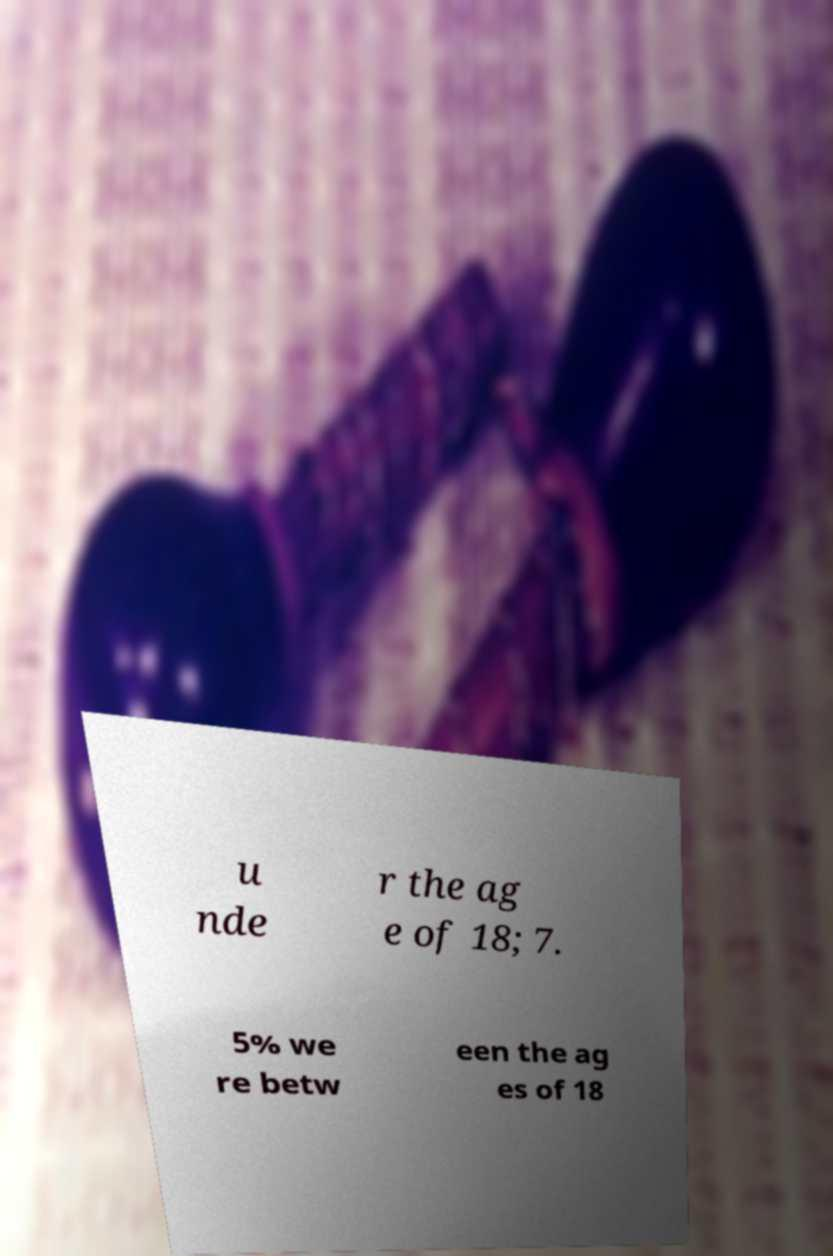Can you accurately transcribe the text from the provided image for me? u nde r the ag e of 18; 7. 5% we re betw een the ag es of 18 